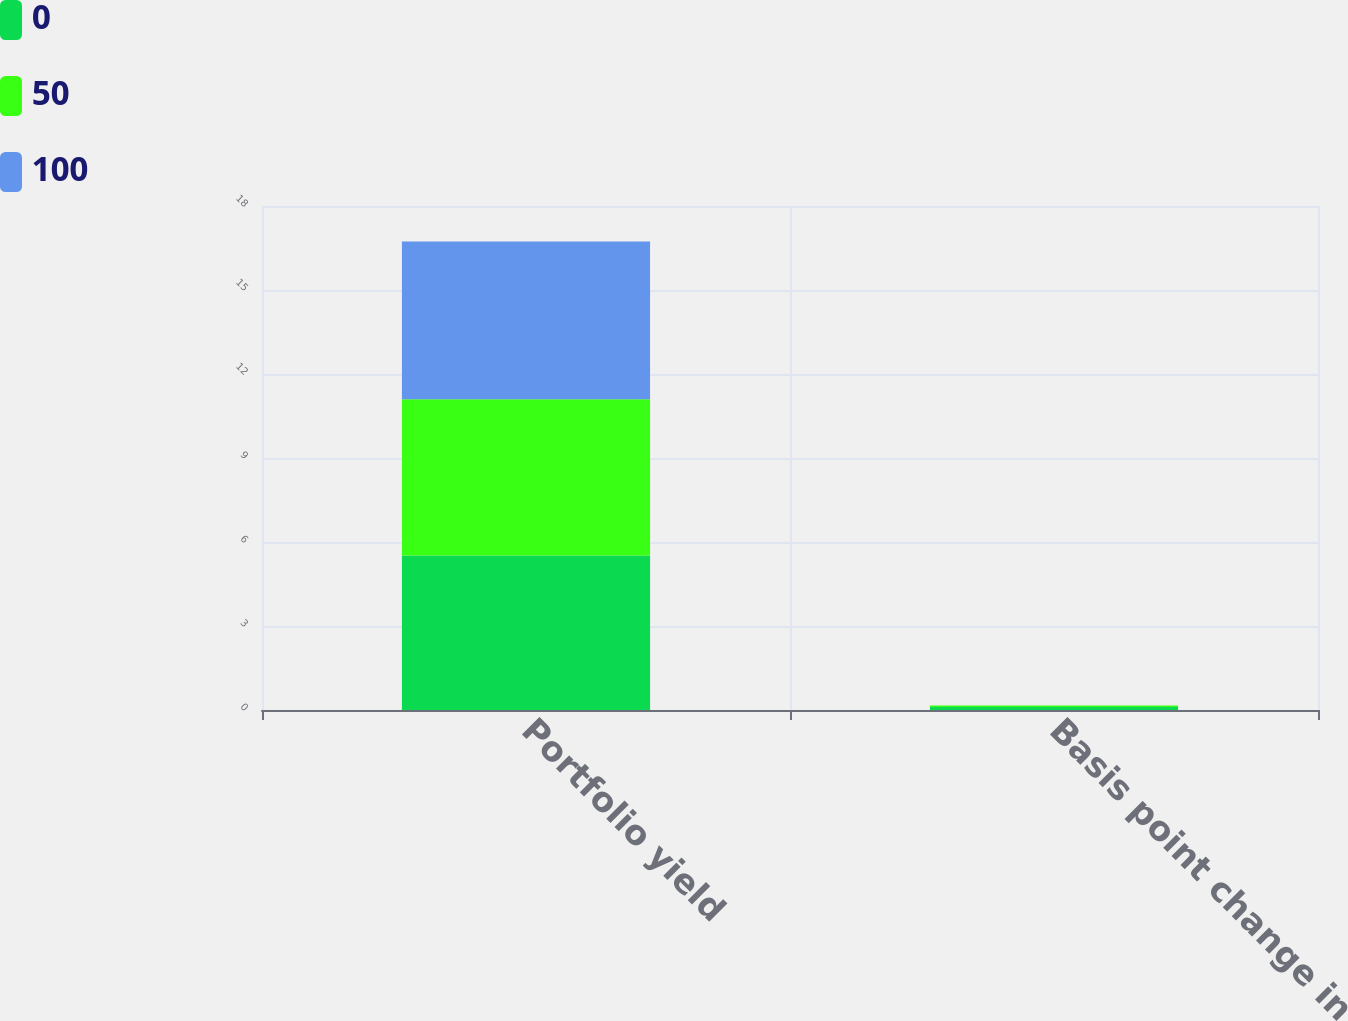Convert chart to OTSL. <chart><loc_0><loc_0><loc_500><loc_500><stacked_bar_chart><ecel><fcel>Portfolio yield<fcel>Basis point change in<nl><fcel>0<fcel>5.52<fcel>0.11<nl><fcel>50<fcel>5.58<fcel>0.05<nl><fcel>100<fcel>5.63<fcel>0<nl></chart> 